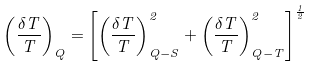<formula> <loc_0><loc_0><loc_500><loc_500>\left ( \frac { \delta T } { T } \right ) _ { Q } = \left [ \left ( \frac { \delta T } { T } \right ) ^ { 2 } _ { Q - S } + \left ( \frac { \delta T } { T } \right ) ^ { 2 } _ { Q - T } \right ] ^ { \frac { 1 } { 2 } }</formula> 